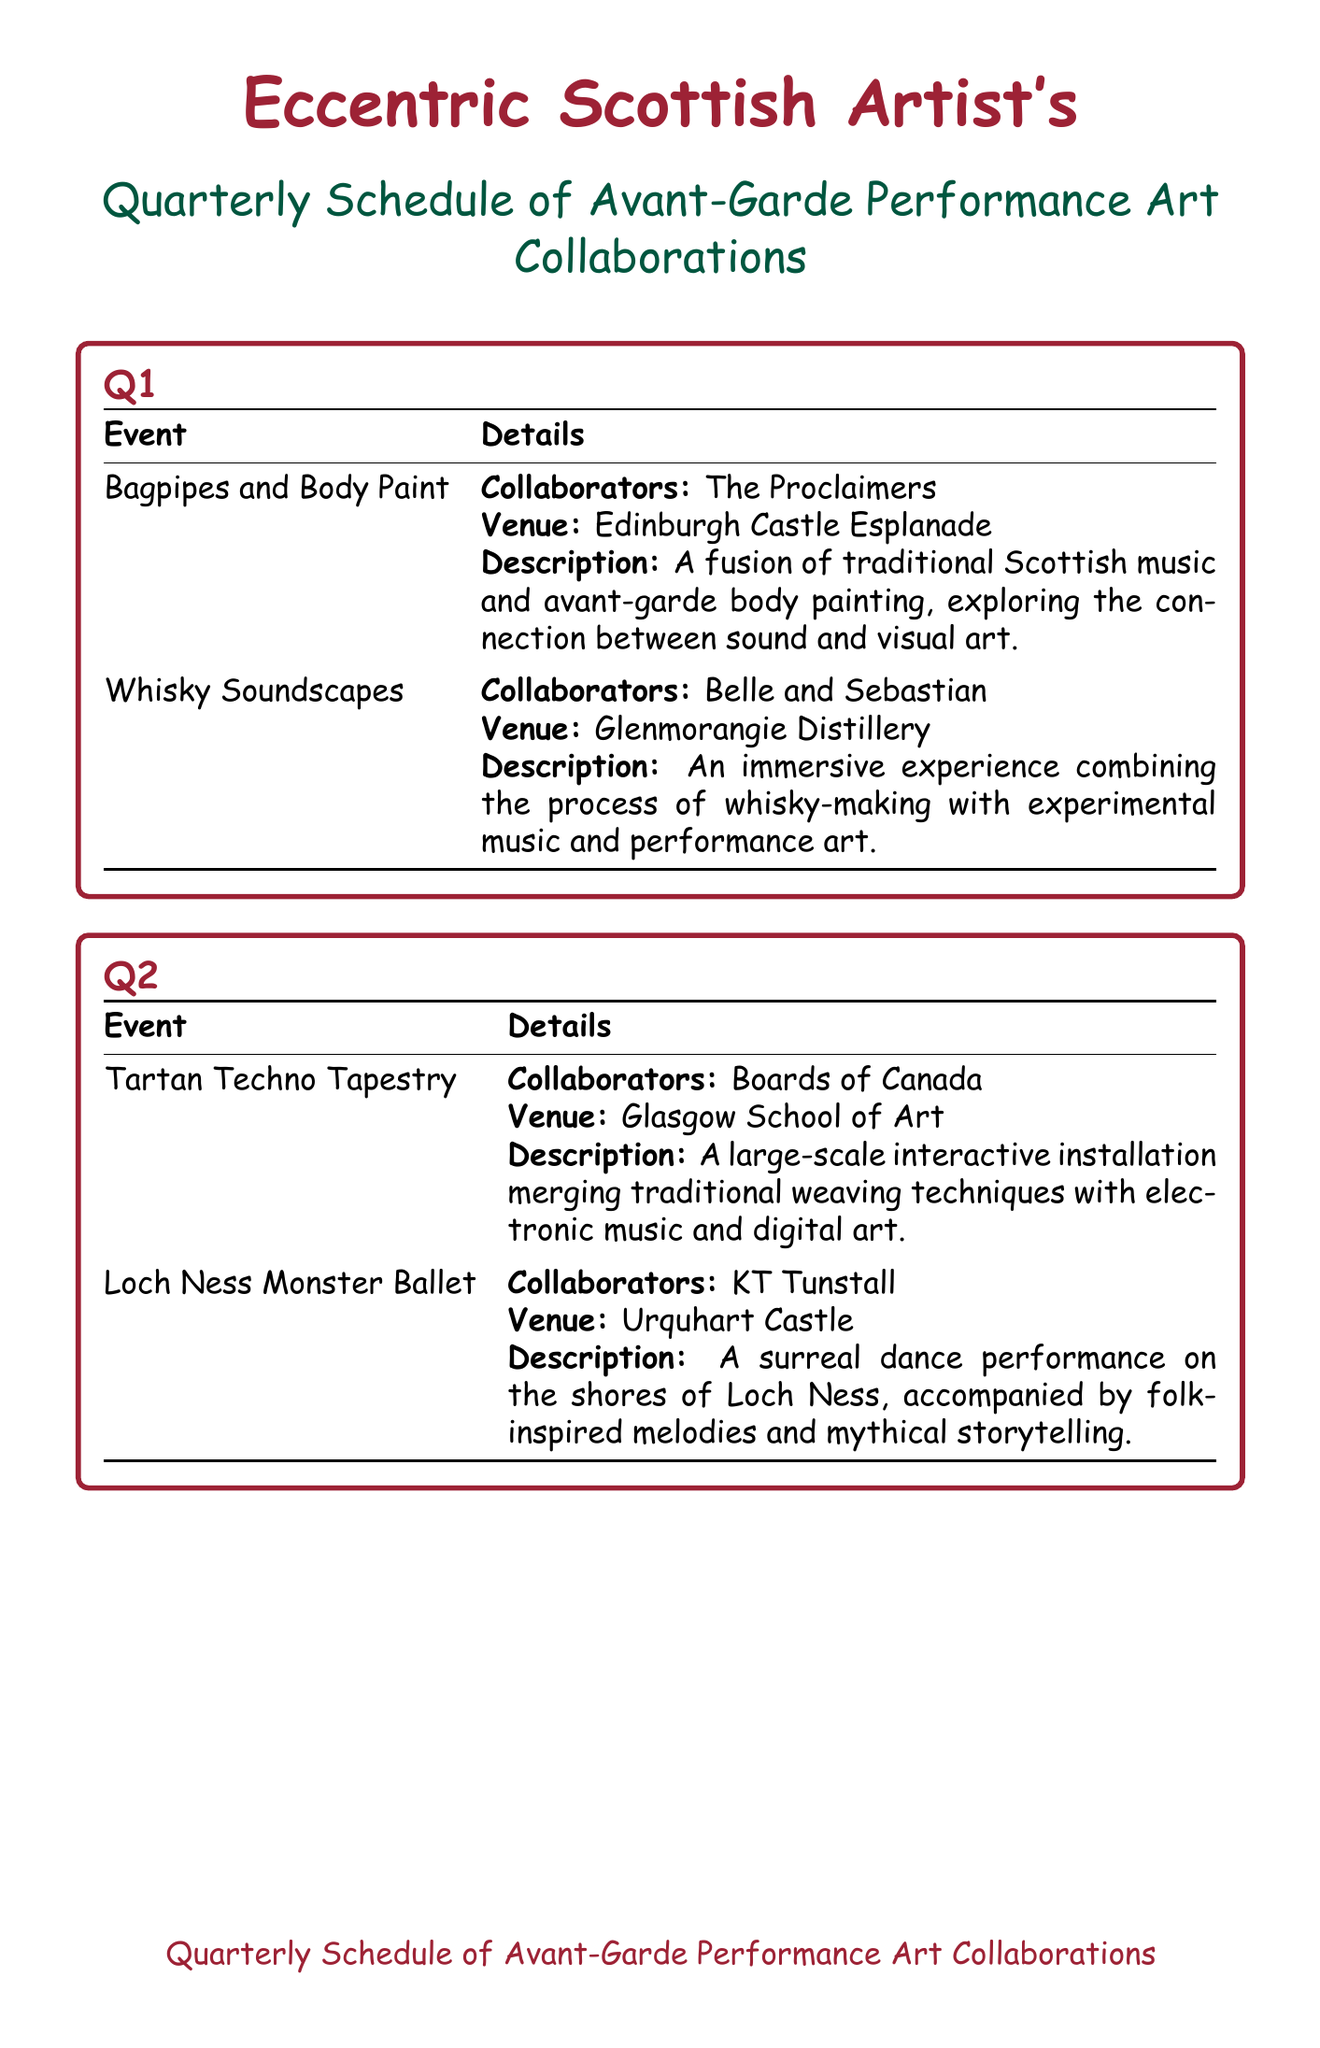What is the name of the event in Q1 that features body painting? The event in Q1 that features body painting is detailed under the name "Bagpipes and Body Paint."
Answer: Bagpipes and Body Paint Who are the collaborators for the "Whisky Soundscapes" event? The "Whisky Soundscapes" event lists "Belle and Sebastian" as the collaborators.
Answer: Belle and Sebastian What venue hosts the "Loch Ness Monster Ballet"? The venue for the "Loch Ness Monster Ballet" is indicated as "Urquhart Castle."
Answer: Urquhart Castle How many events are scheduled in Q3? There are two events scheduled in Q3, as detailed in the document.
Answer: 2 What is the central theme of "Hogmanay Happening"? "Hogmanay Happening" combines performances with a focus on fire and experimental music, creating a New Year's Eve spectacle.
Answer: New Year's Eve spectacle Which event features a collaboration with "Frightened Rabbit"? The event featuring a collaboration with "Frightened Rabbit" is known as "Ceilidh in the Clouds."
Answer: Ceilidh in the Clouds What type of art does "Burns Night Reimagined" incorporate? "Burns Night Reimagined" incorporates post-rock soundscapes and visual projections related to Burns' poetry.
Answer: Post-rock soundscapes Which quarter features events held at "Edinburgh Castle Esplanade"? The quarter featuring events at "Edinburgh Castle Esplanade" is noted as Q1.
Answer: Q1 What is the common artistic aspect explored in the Q2 events? The events in Q2 explore the merging of traditional Scottish art forms with contemporary art techniques.
Answer: Merging of traditional and contemporary art 